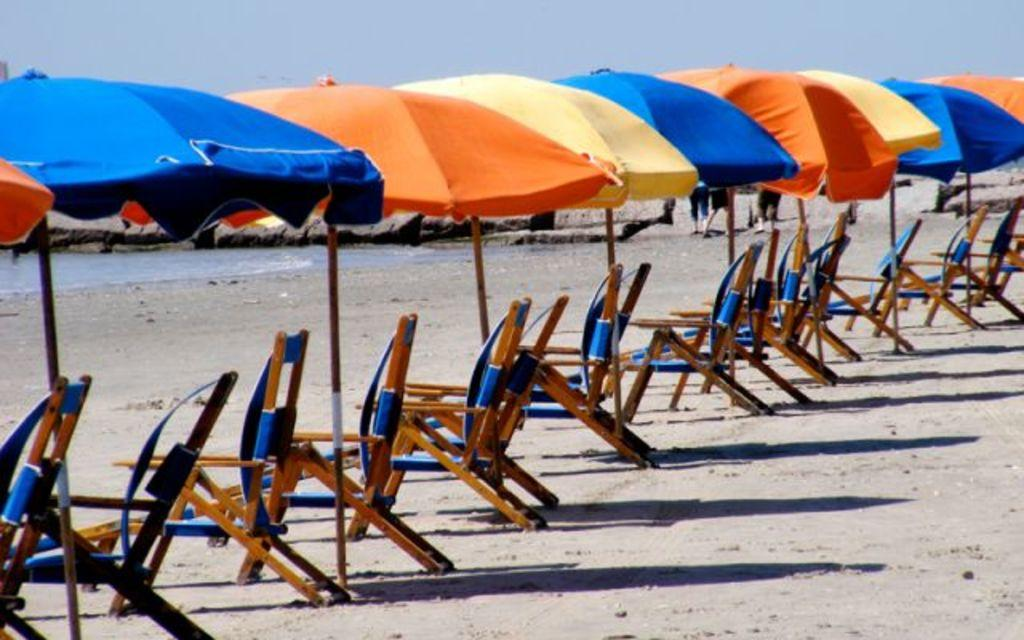What type of furniture is present in the image? There are many chairs in the image. What objects are present to provide shade? There are umbrellas in the image. What can be seen in the distance in the background of the image? There is water and rocks visible in the background of the image. What part of the natural environment is visible in the background of the image? The sky is visible in the background of the image. What type of dress is the fear wearing in the image? There is no person or dress present in the image, and the term "fear" does not apply to any object or subject in the image. 